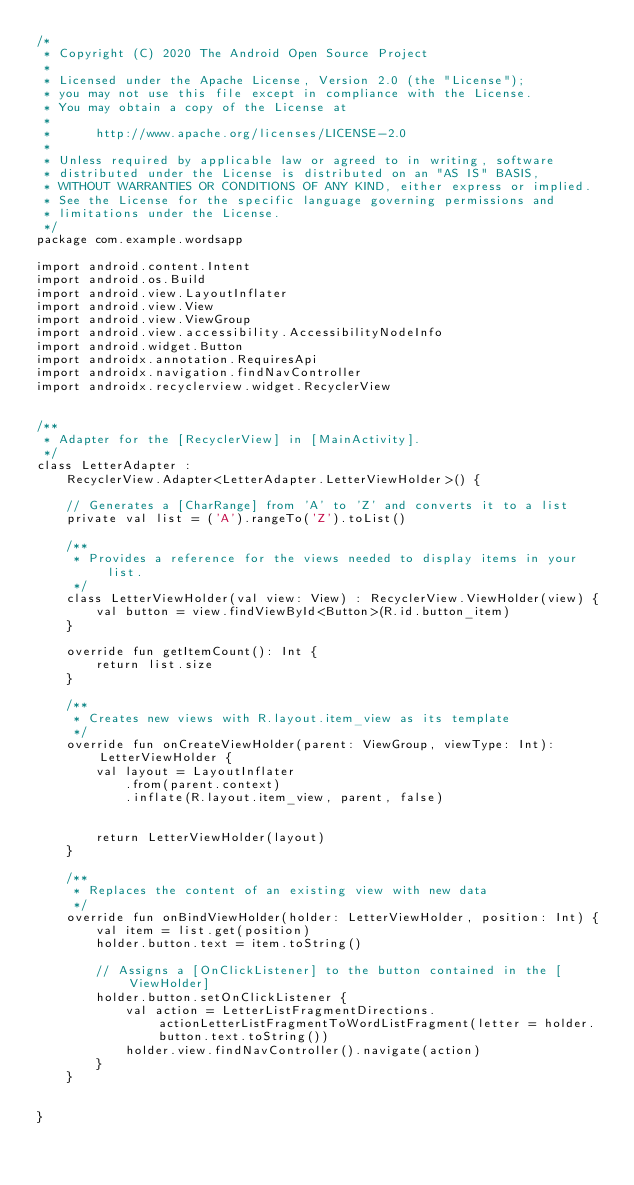<code> <loc_0><loc_0><loc_500><loc_500><_Kotlin_>/*
 * Copyright (C) 2020 The Android Open Source Project
 *
 * Licensed under the Apache License, Version 2.0 (the "License");
 * you may not use this file except in compliance with the License.
 * You may obtain a copy of the License at
 *
 *      http://www.apache.org/licenses/LICENSE-2.0
 *
 * Unless required by applicable law or agreed to in writing, software
 * distributed under the License is distributed on an "AS IS" BASIS,
 * WITHOUT WARRANTIES OR CONDITIONS OF ANY KIND, either express or implied.
 * See the License for the specific language governing permissions and
 * limitations under the License.
 */
package com.example.wordsapp

import android.content.Intent
import android.os.Build
import android.view.LayoutInflater
import android.view.View
import android.view.ViewGroup
import android.view.accessibility.AccessibilityNodeInfo
import android.widget.Button
import androidx.annotation.RequiresApi
import androidx.navigation.findNavController
import androidx.recyclerview.widget.RecyclerView


/**
 * Adapter for the [RecyclerView] in [MainActivity].
 */
class LetterAdapter :
    RecyclerView.Adapter<LetterAdapter.LetterViewHolder>() {

    // Generates a [CharRange] from 'A' to 'Z' and converts it to a list
    private val list = ('A').rangeTo('Z').toList()

    /**
     * Provides a reference for the views needed to display items in your list.
     */
    class LetterViewHolder(val view: View) : RecyclerView.ViewHolder(view) {
        val button = view.findViewById<Button>(R.id.button_item)
    }

    override fun getItemCount(): Int {
        return list.size
    }

    /**
     * Creates new views with R.layout.item_view as its template
     */
    override fun onCreateViewHolder(parent: ViewGroup, viewType: Int): LetterViewHolder {
        val layout = LayoutInflater
            .from(parent.context)
            .inflate(R.layout.item_view, parent, false)
        

        return LetterViewHolder(layout)
    }

    /**
     * Replaces the content of an existing view with new data
     */
    override fun onBindViewHolder(holder: LetterViewHolder, position: Int) {
        val item = list.get(position)
        holder.button.text = item.toString()

        // Assigns a [OnClickListener] to the button contained in the [ViewHolder]
        holder.button.setOnClickListener {
            val action = LetterListFragmentDirections.actionLetterListFragmentToWordListFragment(letter = holder.button.text.toString())
            holder.view.findNavController().navigate(action)
        }
    }


}</code> 